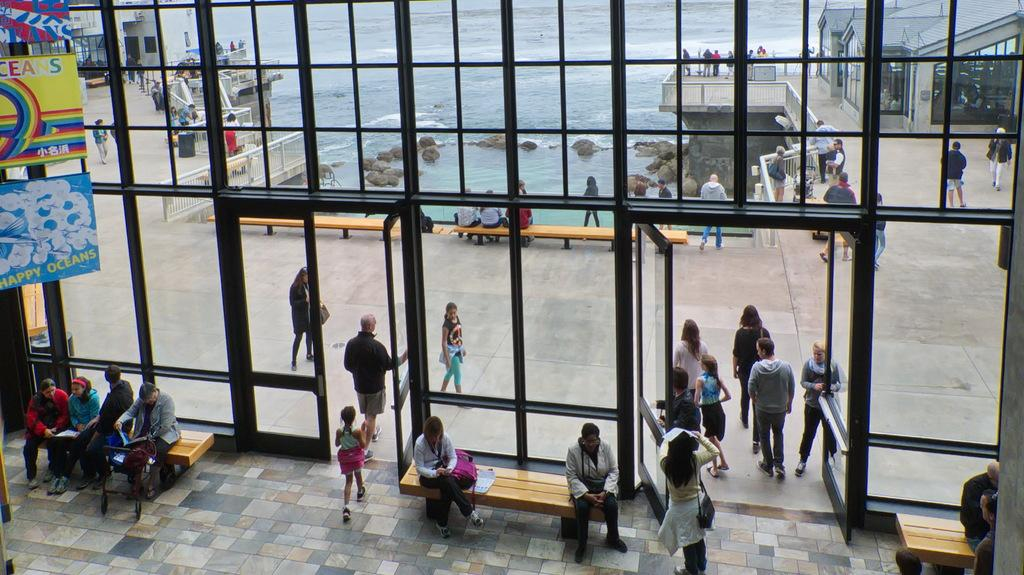What are the people in the image doing? There are persons sitting on a bench and standing on a road in the image. What is the surface beneath the people sitting on the bench? There is a floor in the image. What can be seen in the background of the image? There is a sea visible in the image. What decorative elements are present in the image? There are banners in the image. Can you tell me how many goats are visible in the image? There are no goats present in the image. What type of soda is being served at the event in the image? There is no indication of any soda being served in the image. 